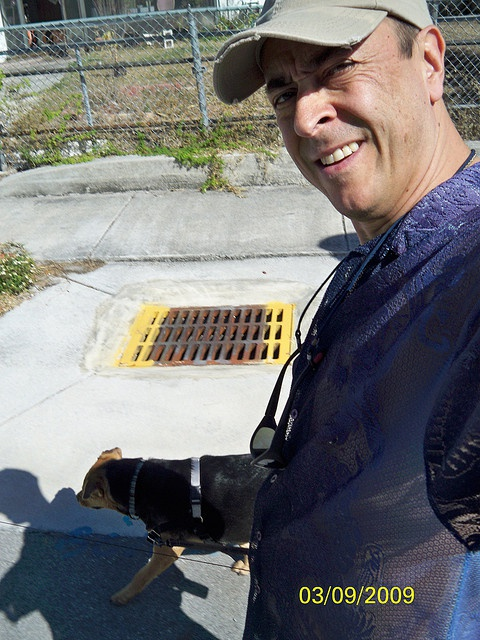Describe the objects in this image and their specific colors. I can see people in gray, black, navy, and tan tones and dog in gray and black tones in this image. 